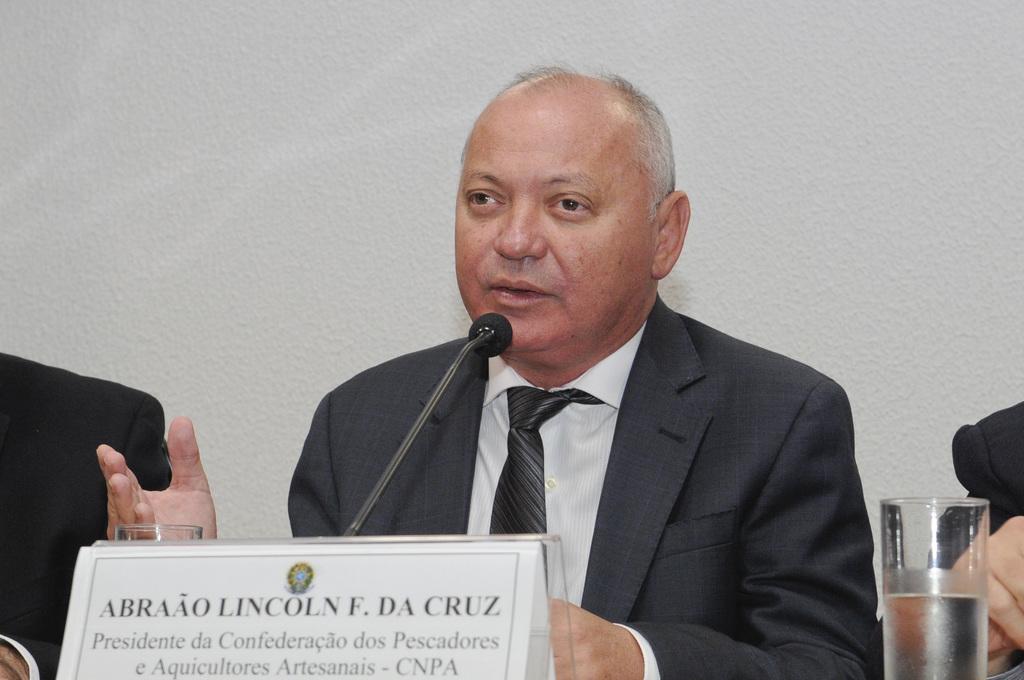Describe this image in one or two sentences. In this image in the front there is a nameplate with some text written on it. In the center there are persons and there are glasses and there is a mic and there is a person speaking on the mic. In the background there is a wall. 